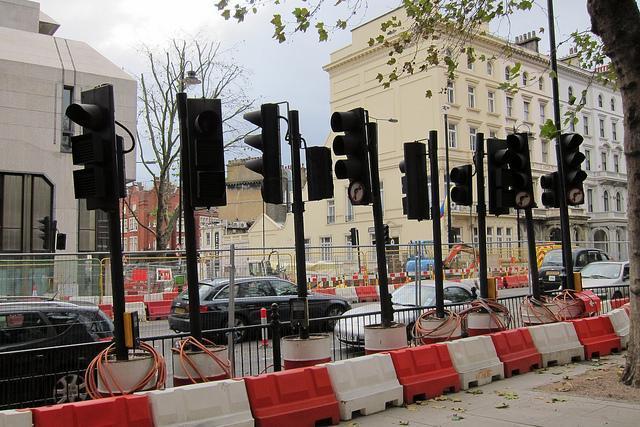How many cars are in the picture?
Give a very brief answer. 3. How many traffic lights are there?
Give a very brief answer. 5. 